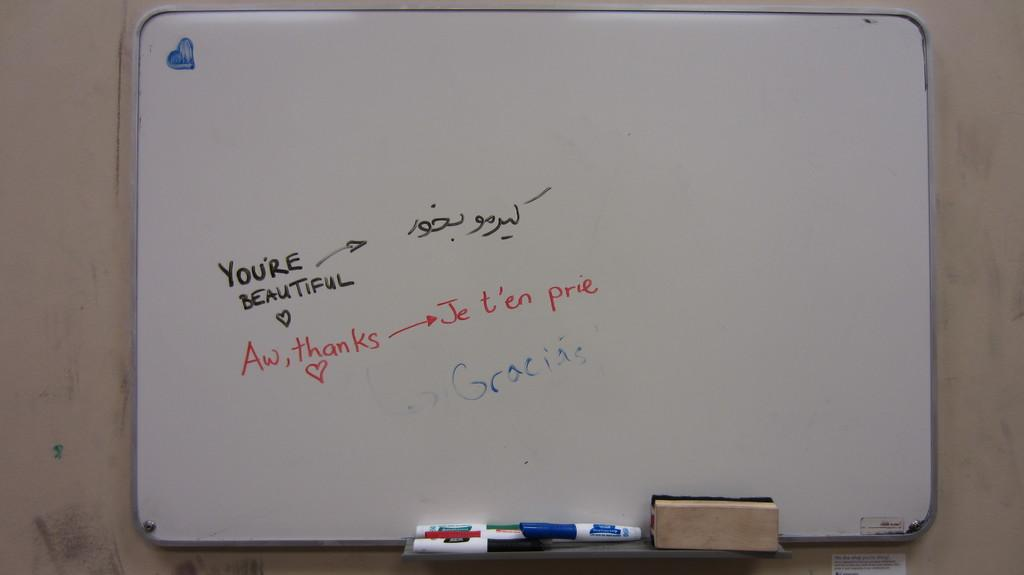<image>
Relay a brief, clear account of the picture shown. A white board says "You're beautiful" with "aw, thanks" written on underneath 